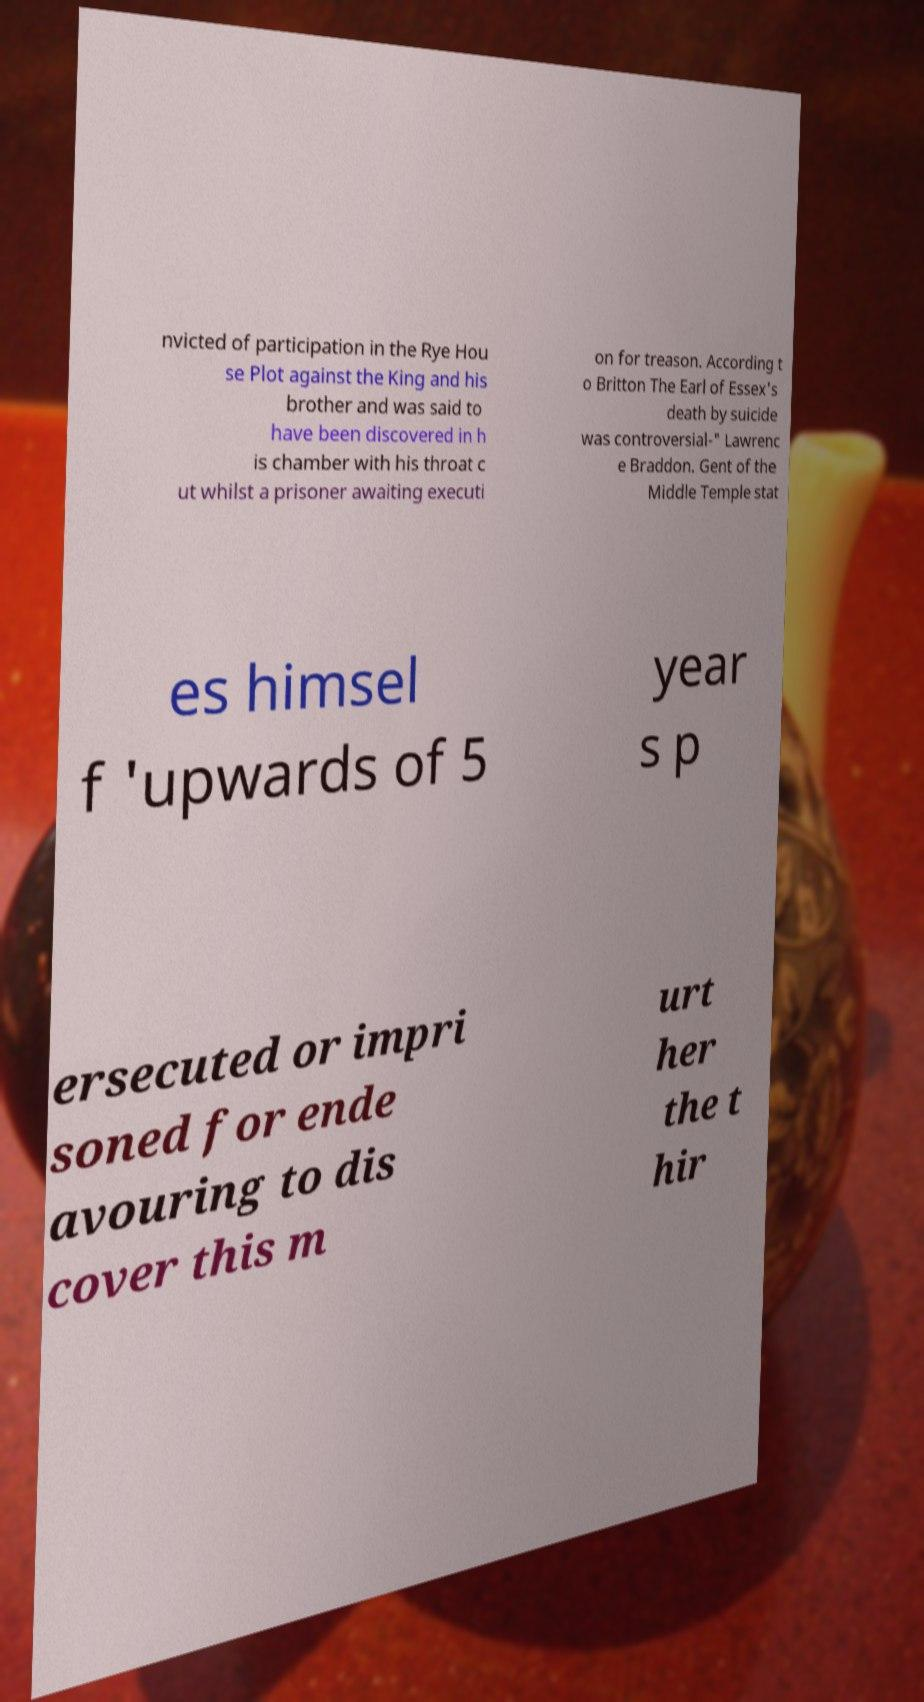What messages or text are displayed in this image? I need them in a readable, typed format. nvicted of participation in the Rye Hou se Plot against the King and his brother and was said to have been discovered in h is chamber with his throat c ut whilst a prisoner awaiting executi on for treason. According t o Britton The Earl of Essex's death by suicide was controversial-" Lawrenc e Braddon. Gent of the Middle Temple stat es himsel f 'upwards of 5 year s p ersecuted or impri soned for ende avouring to dis cover this m urt her the t hir 